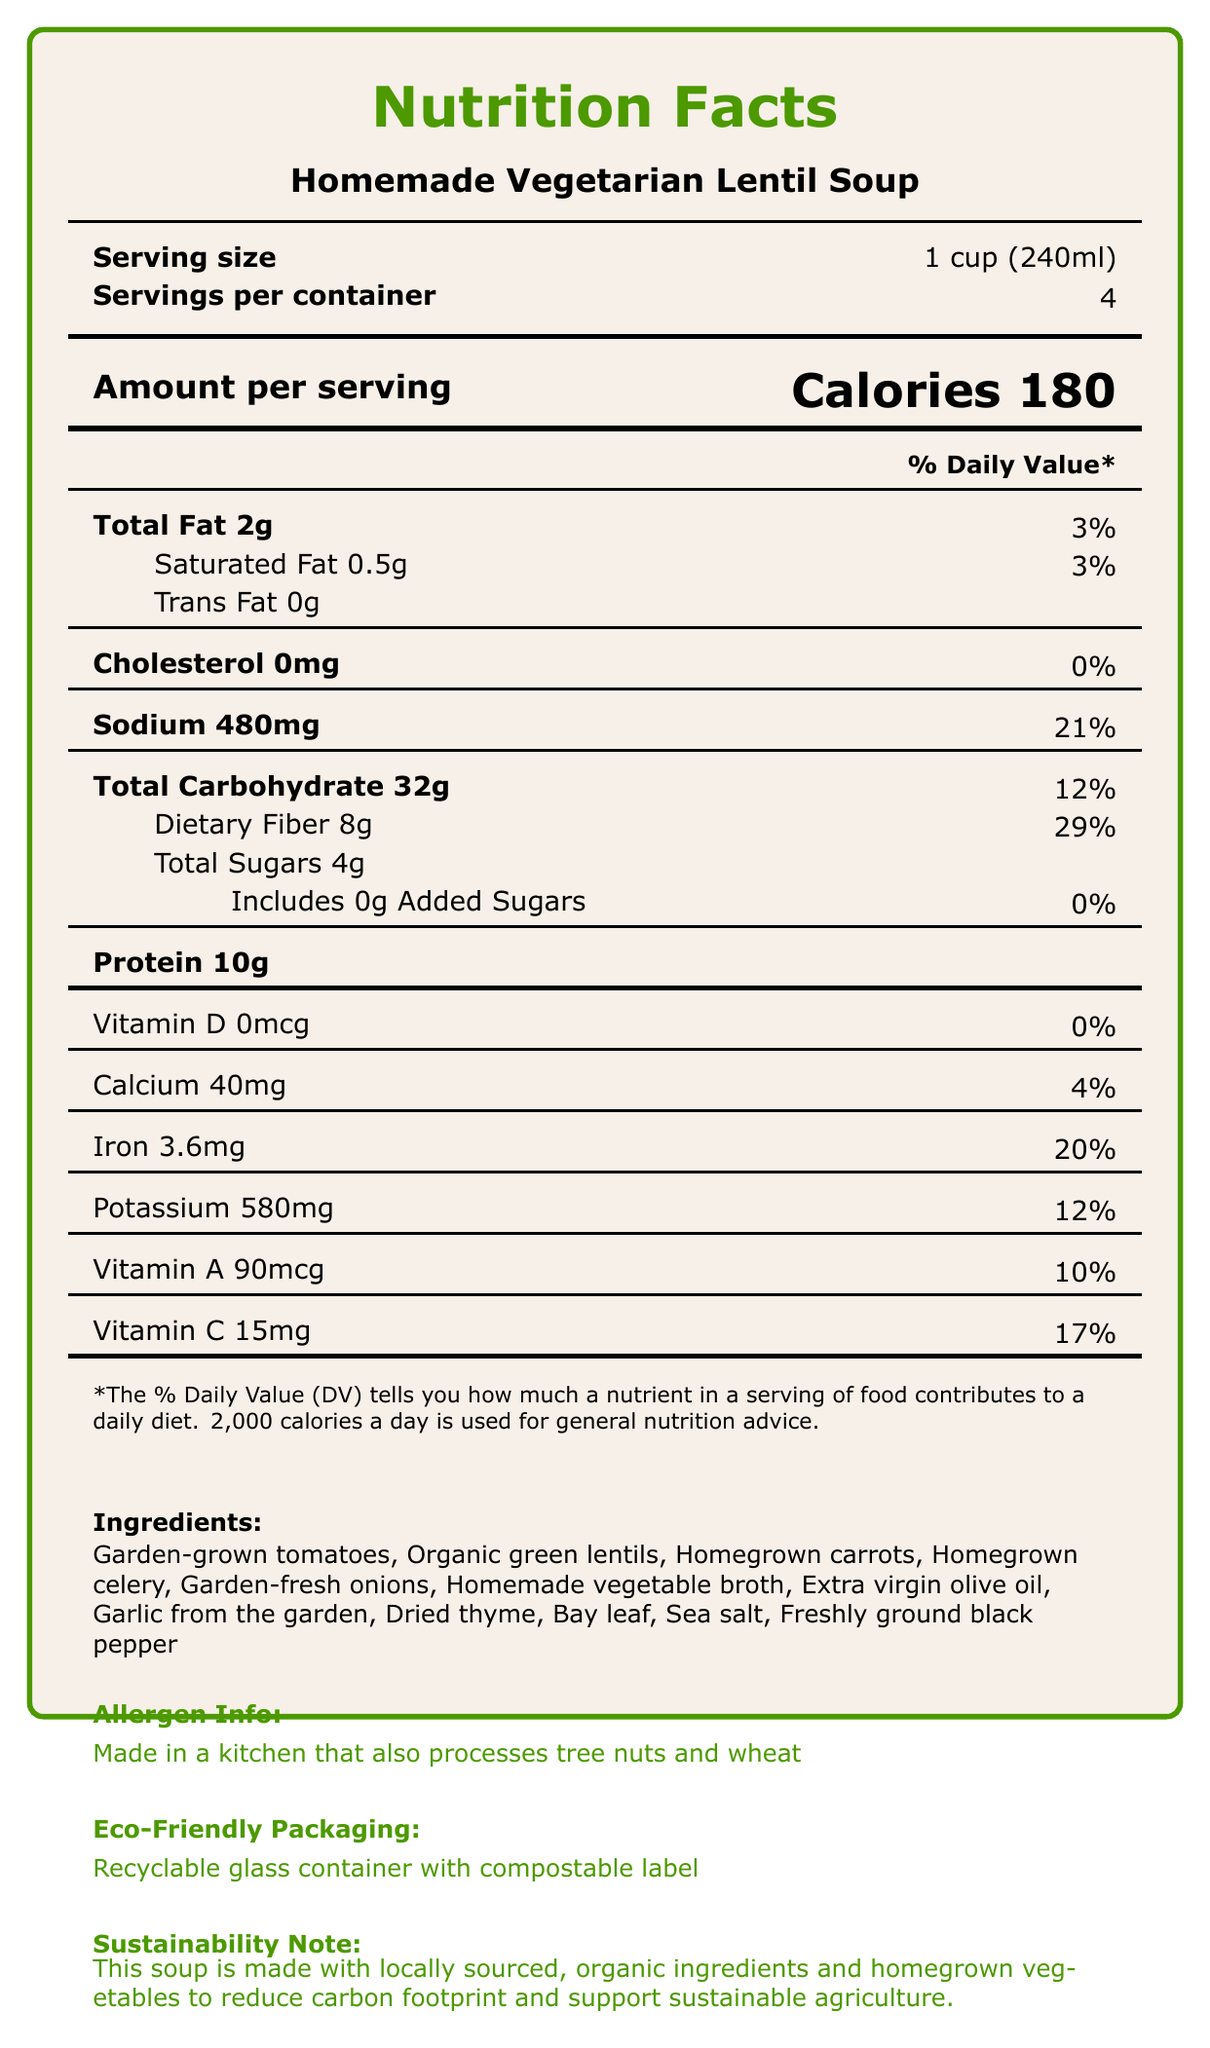what is the serving size? The serving size is stated at the beginning of the document as "1 cup (240ml)".
Answer: 1 cup (240ml) how many servings are in the container? The document specifies "Servings per container" as 4.
Answer: 4 what is the total amount of dietary fiber per serving? The document mentions Dietary Fiber content under the Total Carbohydrate section as 8g per serving.
Answer: 8g what percentage of the daily value of iron does one serving contain? The document lists the daily value of iron as 20% per serving.
Answer: 20% how much sodium is in each serving of the soup? Sodium content per serving is listed as 480mg.
Answer: 480mg how many calories does one serving contain? A. 150 B. 180 C. 200 D. 220 The document states the calorie content as 180 per serving.
Answer: B which ingredient is not listed on the ingredients list? A. Garlic B. Parsley C. Bay leaf D. Tomato The document does not mention parsley; it does include garlic, bay leaf, and tomato.
Answer: B is there any added sugar in this lentil soup? The document states "Includes 0g Added Sugars."
Answer: No does this product contain cholesterol? The document lists the cholesterol content as "0mg."
Answer: No summarize the nutrition and sustainability aspects mentioned in the document. The document gives detailed information on nutrient content per serving and emphasizes the use of sustainable and local ingredients and eco-friendly packaging.
Answer: This document provides nutritional information for a homemade vegetarian lentil soup, indicating it is low in fat, has no cholesterol, and is a good source of protein, dietary fiber, vitamins, and minerals. It uses garden-grown and locally sourced ingredients and comes in eco-friendly packaging to support sustainable agriculture. how long can leftovers be stored in the refrigerator? The document mentions general instructions to store leftovers, but does not specify the exact duration.
Answer: Not enough information what is the percentage daily value of carbohydrates per serving? The document lists the daily value of total carbohydrates as 12%.
Answer: 12% what is the highest percentage daily value nutrient in one serving? The document lists Dietary Fiber with a daily value of 29%, which is the highest among the nutrients.
Answer: Dietary Fiber what type of packaging is used for the soup? A. Plastic container B. Cardboard box C. Glass container D. Metal can The document states that the soup comes in a "Recyclable glass container with compostable label."
Answer: C what is the protein content per serving? The document states that each serving contains 10g of protein.
Answer: 10g 